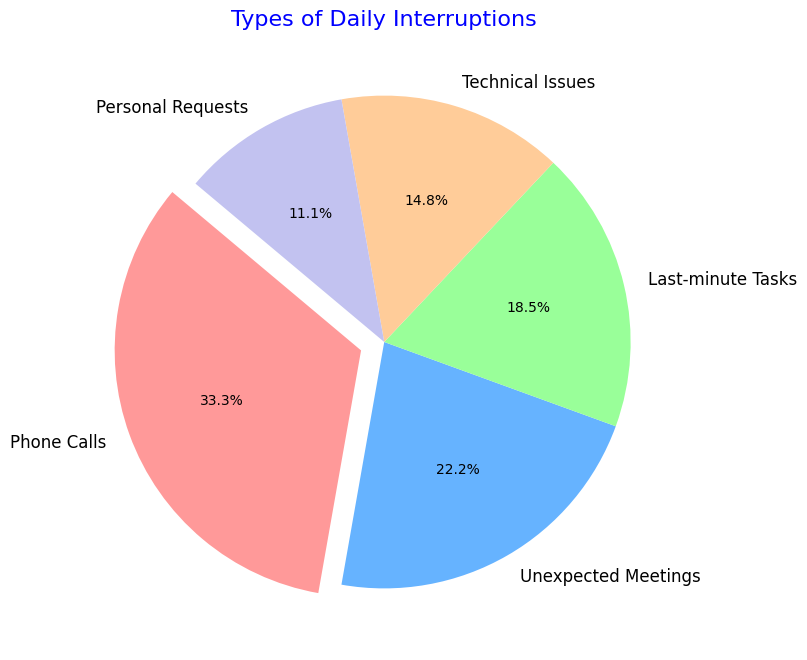Which type of interruption has the highest percentage? By looking at the pie chart, the largest slice represents the category with the highest percentage. Phone Calls is the largest slice.
Answer: Phone Calls What percentage of interruptions are due to Technical Issues and Personal Requests combined? The chart shows Technical Issues at 20% and Personal Requests at 15%. Adding these gives 20% + 15% = 35%.
Answer: 35% Which color represents Last-minute Tasks? The pie chart uses different colors for each category. Looking for Last-minute Tasks, it is represented by the third color, which is a light green.
Answer: Light Green Are Unexpected Meetings more frequent than Technical Issues? By comparing the sizes of the slices, Unexpected Meetings appear larger than Technical Issues. The figure shows 30% for Unexpected Meetings and 20% for Technical Issues. Therefore, yes, Unexpected Meetings are more frequent.
Answer: Yes What is the difference in percentage between Phone Calls and Personal Requests? Phone Calls represent 45%, and Personal Requests represent 15%. To find the difference, subtract 15% from 45% which gives 45% - 15% = 30%.
Answer: 30% Which interruption type is represented by the smallest slice in the chart? By examining the pie chart, the smallest slice is clearly visible. Personal Requests are the smallest slice at 15%.
Answer: Personal Requests How much more frequent are Phone Calls compared to Last-minute Tasks? Phone Calls make up 45% of the chart, and Last-minute Tasks make up 25%. Subtracting these, 45% - 25% = 20%.
Answer: 20% What is the combined percentage of Phone Calls, Unexpected Meetings, and Last-minute Tasks? The percentages are 45% for Phone Calls, 30% for Unexpected Meetings, and 25% for Last-minute Tasks. Adding these gives 45% + 30% + 25% = 100%.
Answer: 100% 